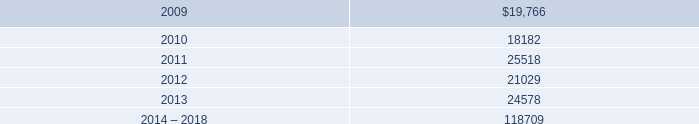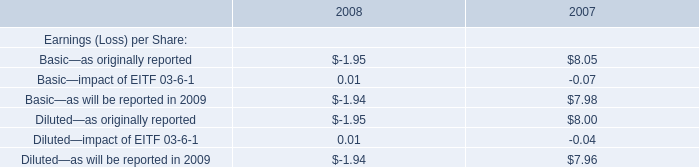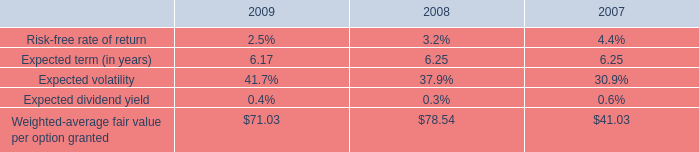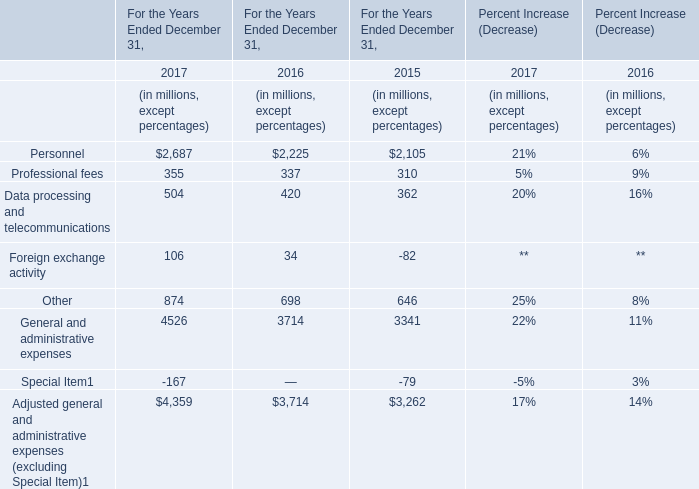Does the value of Professional fees in 2016 greater than that in 2017? 
Answer: No. 